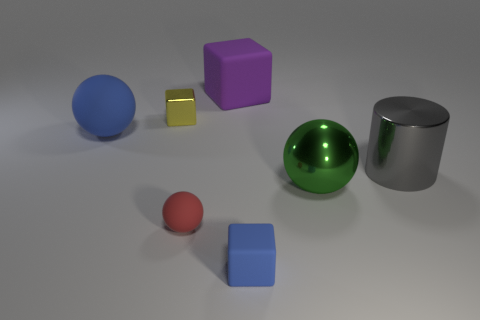Add 2 small green metallic things. How many objects exist? 9 Subtract all cylinders. How many objects are left? 6 Add 3 big blue things. How many big blue things are left? 4 Add 1 big cubes. How many big cubes exist? 2 Subtract 1 gray cylinders. How many objects are left? 6 Subtract all rubber spheres. Subtract all large green things. How many objects are left? 4 